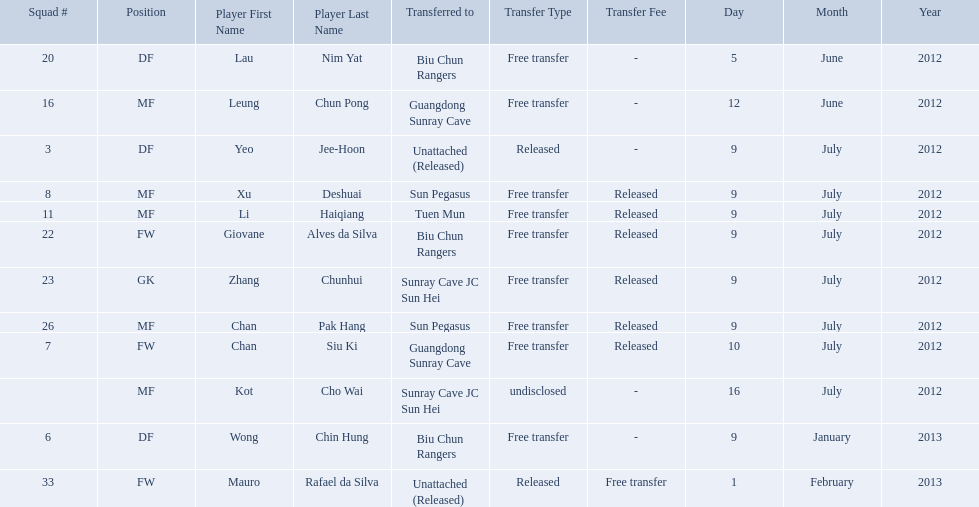Which players are listed? Lau Nim Yat, Leung Chun Pong, Yeo Jee-Hoon, Xu Deshuai, Li Haiqiang, Giovane Alves da Silva, Zhang Chunhui, Chan Pak Hang, Chan Siu Ki, Kot Cho Wai, Wong Chin Hung, Mauro Rafael da Silva. Which dates were players transferred to the biu chun rangers? 5 June 2012, 9 July 2012, 9 January 2013. Of those which is the date for wong chin hung? 9 January 2013. 